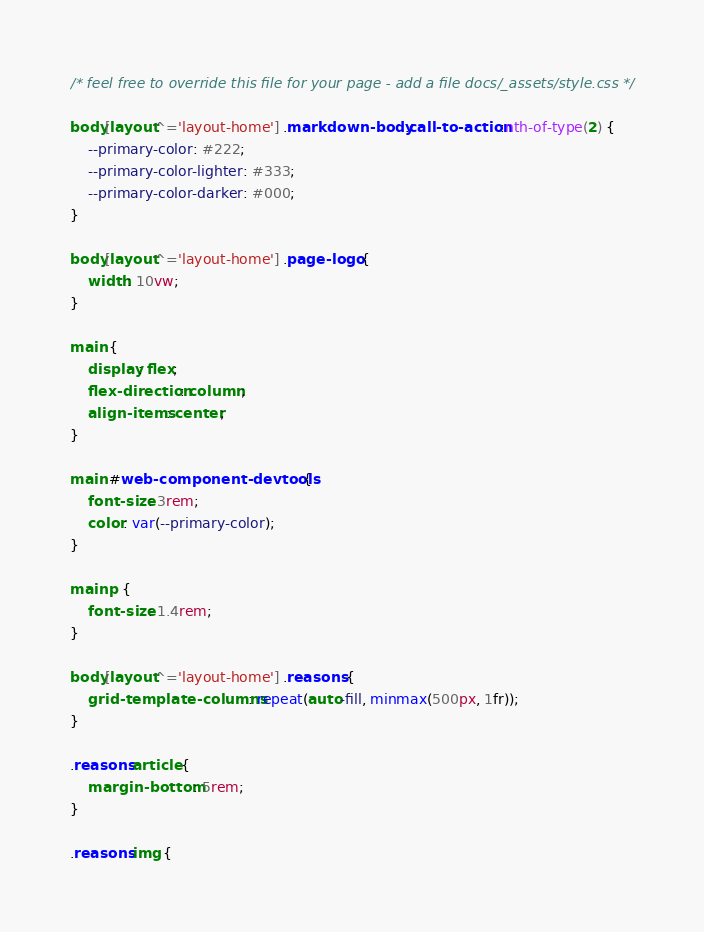Convert code to text. <code><loc_0><loc_0><loc_500><loc_500><_CSS_>/* feel free to override this file for your page - add a file docs/_assets/style.css */

body[layout^='layout-home'] .markdown-body .call-to-action:nth-of-type(2) {
    --primary-color: #222;
    --primary-color-lighter: #333;
    --primary-color-darker: #000;
}

body[layout^='layout-home'] .page-logo {
    width: 10vw;
}

main {
    display: flex;
    flex-direction: column;
    align-items: center;
}

main #web-component-devtools {
    font-size: 3rem;
    color: var(--primary-color);
}

main p {
    font-size: 1.4rem;
}

body[layout^='layout-home'] .reasons {
    grid-template-columns: repeat(auto-fill, minmax(500px, 1fr));
}

.reasons article {
    margin-bottom: 5rem;
}

.reasons img {</code> 